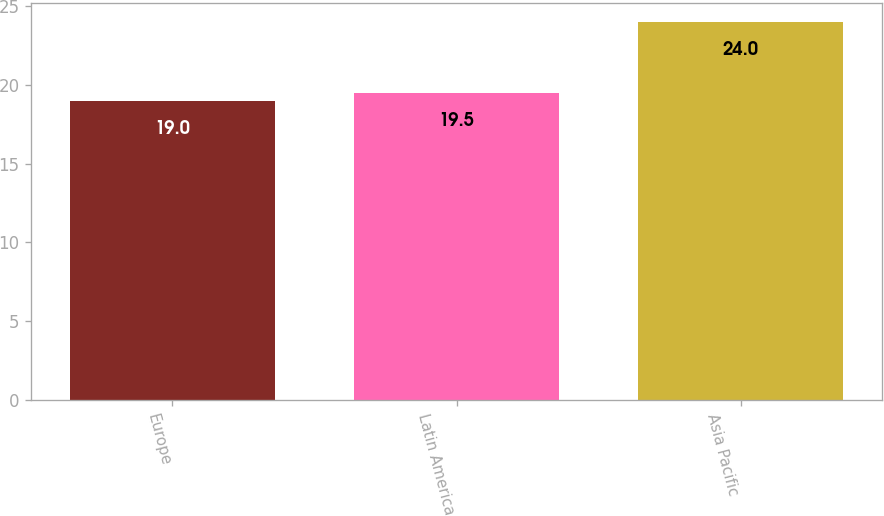Convert chart to OTSL. <chart><loc_0><loc_0><loc_500><loc_500><bar_chart><fcel>Europe<fcel>Latin America<fcel>Asia Pacific<nl><fcel>19<fcel>19.5<fcel>24<nl></chart> 